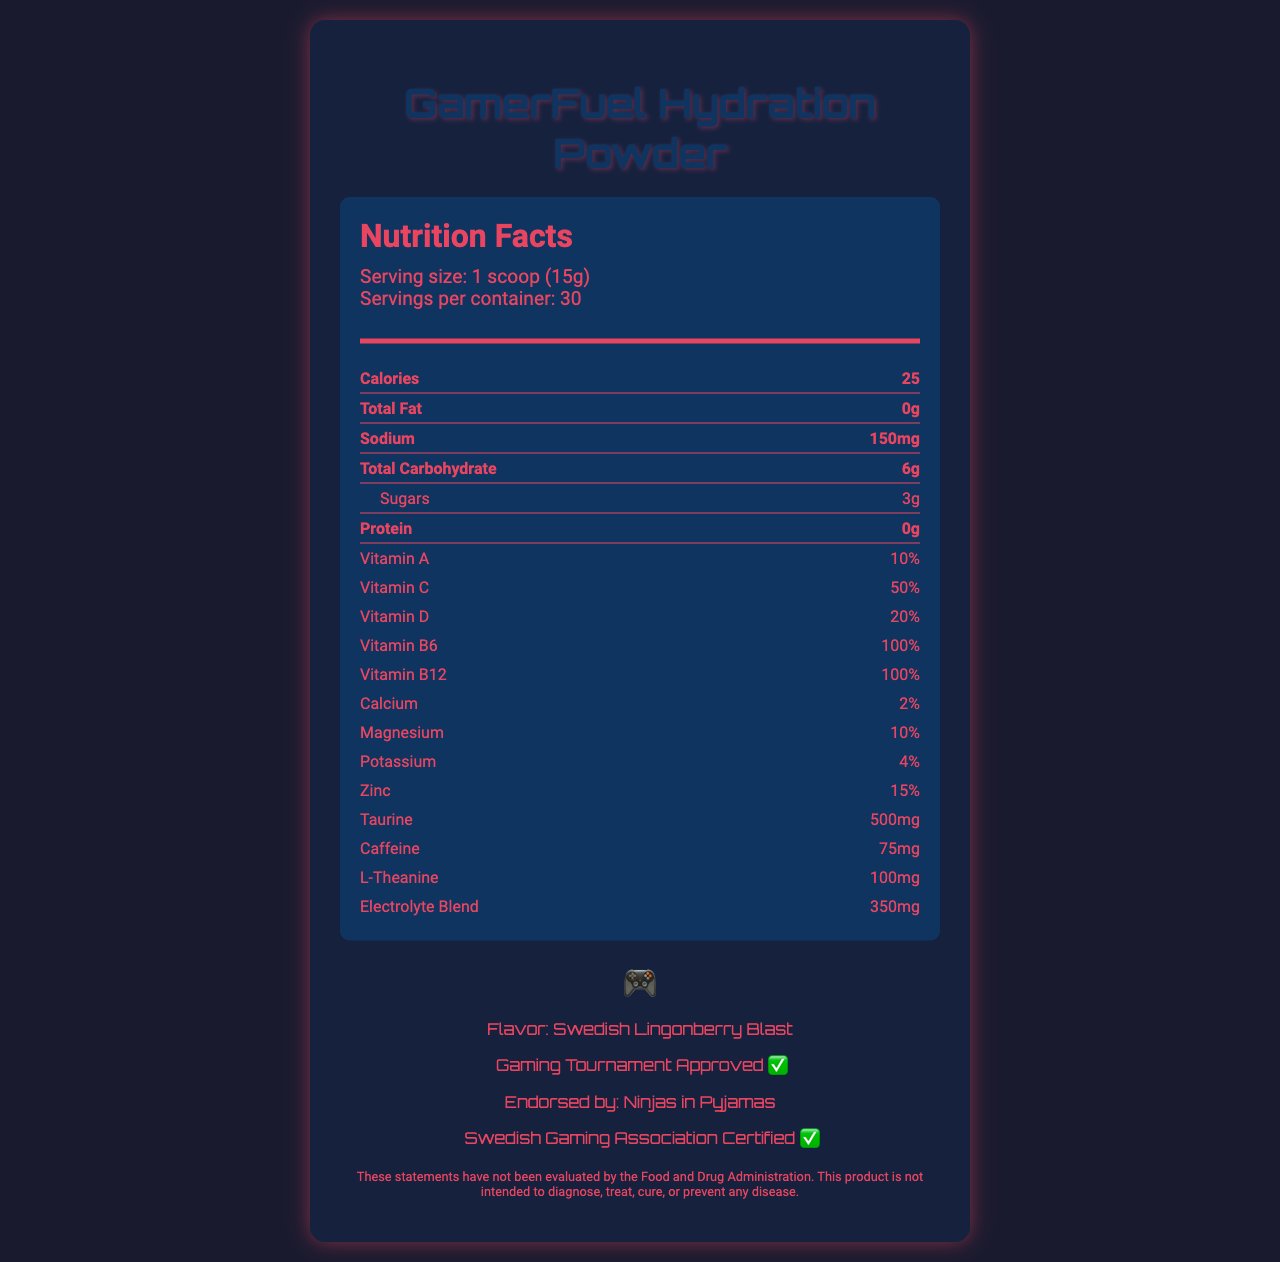what is the serving size? The serving size is explicitly stated in the serving info section.
Answer: 1 scoop (15g) how many calories are in one serving? The nutrition label shows that there are 25 calories per serving.
Answer: 25 how much sodium is in each serving? The nutrition facts list sodium content as 150mg per serving.
Answer: 150mg which vitamins are present in the hydration powder? The nutrition label lists Vitamin A, Vitamin C, Vitamin D, Vitamin B6, and Vitamin B12 along with their respective percentages.
Answer: Vitamin A, Vitamin C, Vitamin D, Vitamin B6, Vitamin B12 what is the flavor of the GamerFuel Hydration Powder? The gaming info section mentions that the flavor is Swedish Lingonberry Blast.
Answer: Swedish Lingonberry Blast how much caffeine does one serving contain? The nutrition label specifies that each serving contains 75mg of caffeine.
Answer: 75mg is the hydration powder endorsed by an esports team? The gaming info mentions that it is endorsed by Ninjas in Pyjamas.
Answer: Yes which of the following minerals are in the hydration blend? A. Iron B. Calcium C. Magnesium D. Potassium The nutrition label lists Calcium, Magnesium, and Potassium but does not mention Iron.
Answer: B, C, D what is the total carbohydrate content per serving? A. 3g B. 6g C. 9g D. 12g The nutrition label shows that the total carbohydrate content per serving is 6 grams.
Answer: B can this product be used to diagnose or treat diseases? The disclaimer clearly states that the product is not intended to diagnose, treat, cure, or prevent any disease.
Answer: No how many servings are in one container? The serving info section mentions that there are 30 servings per container.
Answer: 30 describe the main idea of the document. The document provides comprehensive nutrition information along with endorsements and flavor details about the GamerFuel Hydration Powder meant for gamers.
Answer: The document details the nutrition facts for GamerFuel Hydration Powder, a vitamin-fortified drink designed for gamers. It includes information about serving size, nutritional content, vitamins and minerals, flavor, and endorsements from an esports team and gaming associations. what is the primary function of L-Theanine in the hydration powder? The document lists L-Theanine but does not provide details about its function.
Answer: Not enough information 